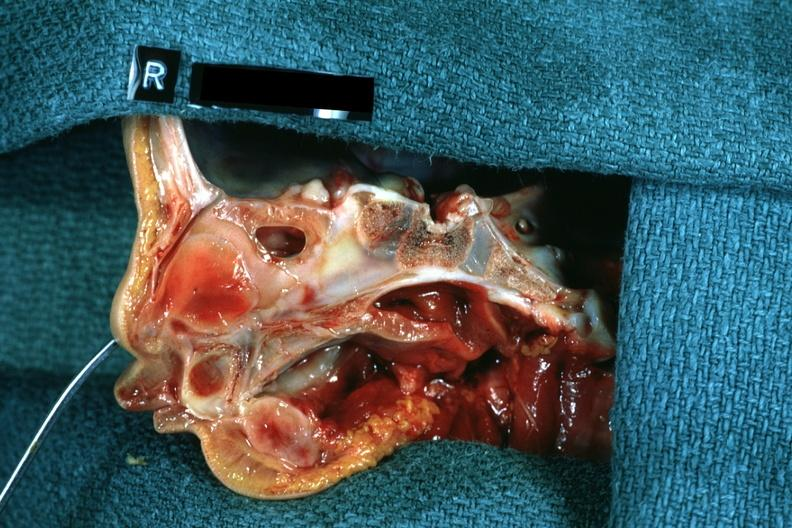does this image show right side atresia left was patent hemisection of nose?
Answer the question using a single word or phrase. Yes 